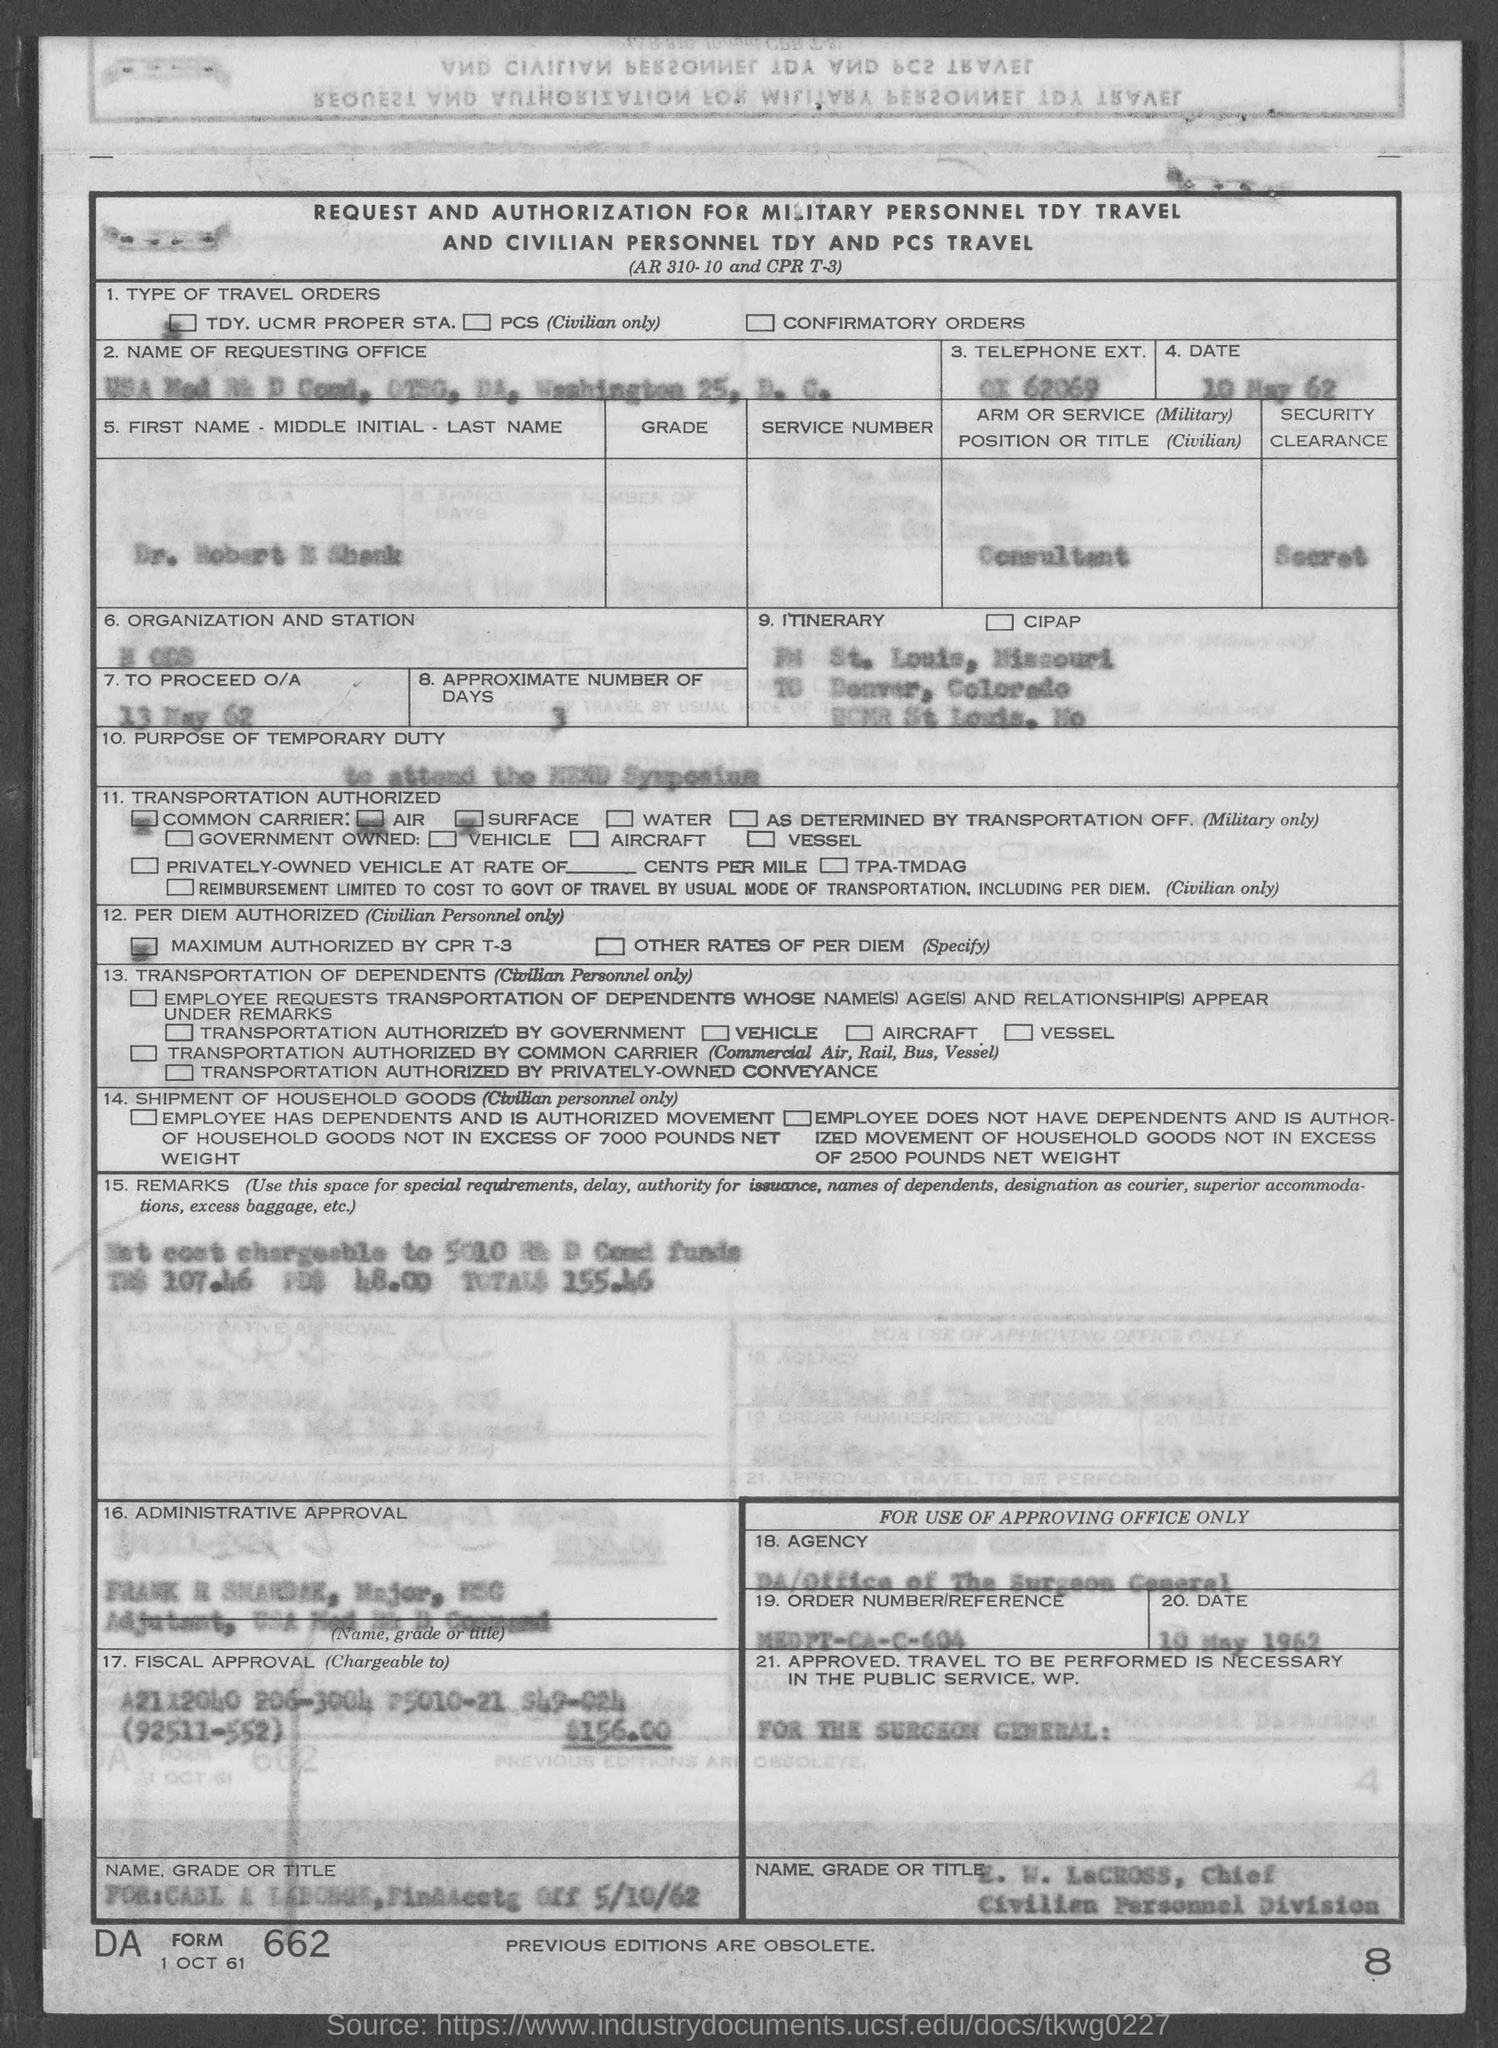What is the date given for to proceed o/a as mentioned in the given form ?
Give a very brief answer. 13 May 62. 